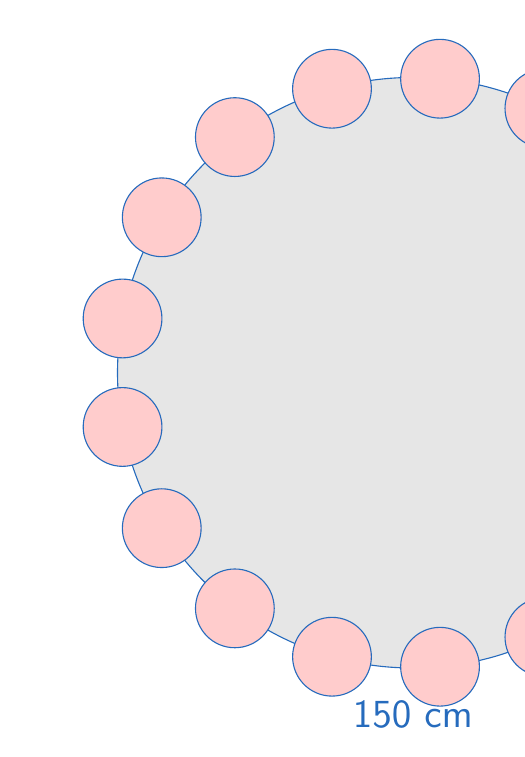Give your solution to this math problem. Let's approach this step-by-step:

1) First, we need to calculate the circumference of the table:
   $$ C = \pi d = \pi \times 150 \approx 471.24 \text{ cm} $$

2) Now, we need to determine the space each plate occupies, including the gap:
   Plate diameter + gap = 20 cm + 5 cm = 25 cm

3) To find the maximum number of plates, we divide the circumference by the space each plate occupies:
   $$ n = \frac{C}{25} = \frac{471.24}{25} \approx 18.85 $$

4) Since we can't have a fraction of a plate, we round down to the nearest whole number:
   $$ n = 18 $$

5) To verify, let's calculate the actual space needed for 18 plates:
   $$ 18 \times 25 = 450 \text{ cm} $$

6) This is less than the circumference (471.24 cm), so it fits.

7) If we try 19 plates:
   $$ 19 \times 25 = 475 \text{ cm} $$
   This exceeds the circumference, confirming that 18 is indeed the maximum.

Therefore, the maximum number of plates that can fit around the table under these conditions is 18.
Answer: 18 plates 